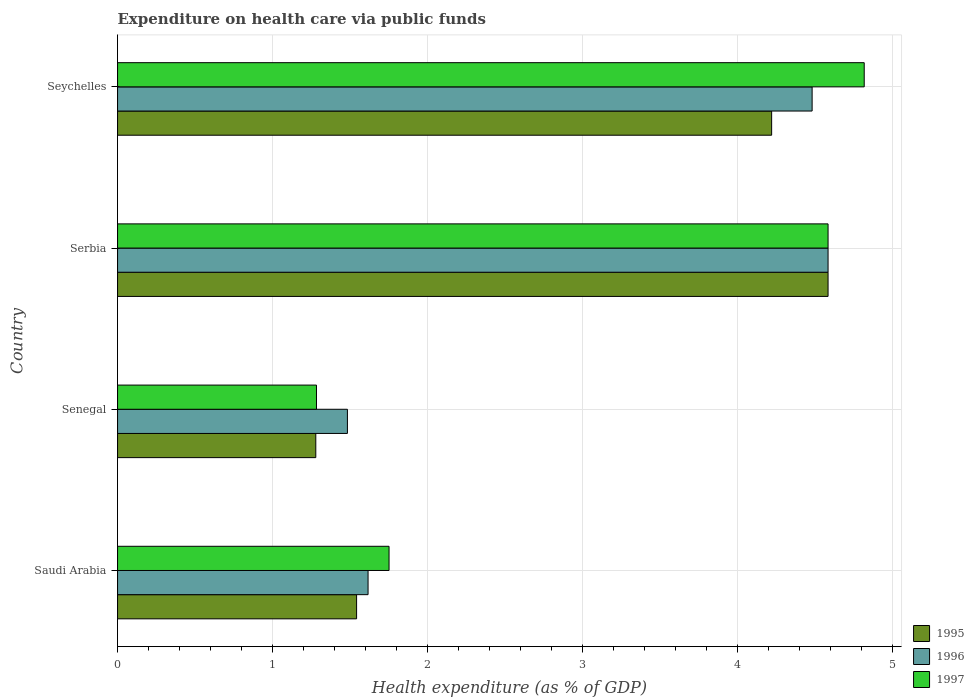How many different coloured bars are there?
Provide a short and direct response. 3. How many bars are there on the 2nd tick from the top?
Provide a short and direct response. 3. What is the label of the 2nd group of bars from the top?
Your answer should be compact. Serbia. In how many cases, is the number of bars for a given country not equal to the number of legend labels?
Provide a succinct answer. 0. What is the expenditure made on health care in 1996 in Saudi Arabia?
Your answer should be very brief. 1.62. Across all countries, what is the maximum expenditure made on health care in 1997?
Your answer should be very brief. 4.82. Across all countries, what is the minimum expenditure made on health care in 1995?
Provide a short and direct response. 1.28. In which country was the expenditure made on health care in 1995 maximum?
Offer a very short reply. Serbia. In which country was the expenditure made on health care in 1997 minimum?
Ensure brevity in your answer.  Senegal. What is the total expenditure made on health care in 1997 in the graph?
Provide a succinct answer. 12.44. What is the difference between the expenditure made on health care in 1996 in Senegal and that in Seychelles?
Provide a short and direct response. -3. What is the difference between the expenditure made on health care in 1995 in Serbia and the expenditure made on health care in 1996 in Seychelles?
Offer a terse response. 0.1. What is the average expenditure made on health care in 1995 per country?
Ensure brevity in your answer.  2.91. What is the difference between the expenditure made on health care in 1997 and expenditure made on health care in 1995 in Senegal?
Ensure brevity in your answer.  0. In how many countries, is the expenditure made on health care in 1997 greater than 4.4 %?
Keep it short and to the point. 2. What is the ratio of the expenditure made on health care in 1997 in Saudi Arabia to that in Serbia?
Provide a succinct answer. 0.38. Is the difference between the expenditure made on health care in 1997 in Senegal and Seychelles greater than the difference between the expenditure made on health care in 1995 in Senegal and Seychelles?
Keep it short and to the point. No. What is the difference between the highest and the second highest expenditure made on health care in 1995?
Provide a succinct answer. 0.36. What is the difference between the highest and the lowest expenditure made on health care in 1997?
Keep it short and to the point. 3.54. What does the 3rd bar from the top in Saudi Arabia represents?
Give a very brief answer. 1995. Is it the case that in every country, the sum of the expenditure made on health care in 1997 and expenditure made on health care in 1996 is greater than the expenditure made on health care in 1995?
Provide a short and direct response. Yes. What is the difference between two consecutive major ticks on the X-axis?
Keep it short and to the point. 1. Does the graph contain any zero values?
Your answer should be compact. No. Does the graph contain grids?
Give a very brief answer. Yes. How many legend labels are there?
Give a very brief answer. 3. What is the title of the graph?
Your answer should be very brief. Expenditure on health care via public funds. What is the label or title of the X-axis?
Provide a short and direct response. Health expenditure (as % of GDP). What is the Health expenditure (as % of GDP) in 1995 in Saudi Arabia?
Your answer should be compact. 1.54. What is the Health expenditure (as % of GDP) in 1996 in Saudi Arabia?
Give a very brief answer. 1.62. What is the Health expenditure (as % of GDP) of 1997 in Saudi Arabia?
Your response must be concise. 1.75. What is the Health expenditure (as % of GDP) of 1995 in Senegal?
Offer a very short reply. 1.28. What is the Health expenditure (as % of GDP) of 1996 in Senegal?
Provide a short and direct response. 1.48. What is the Health expenditure (as % of GDP) of 1997 in Senegal?
Give a very brief answer. 1.28. What is the Health expenditure (as % of GDP) of 1995 in Serbia?
Provide a succinct answer. 4.59. What is the Health expenditure (as % of GDP) in 1996 in Serbia?
Your response must be concise. 4.59. What is the Health expenditure (as % of GDP) in 1997 in Serbia?
Provide a short and direct response. 4.59. What is the Health expenditure (as % of GDP) in 1995 in Seychelles?
Ensure brevity in your answer.  4.22. What is the Health expenditure (as % of GDP) of 1996 in Seychelles?
Ensure brevity in your answer.  4.48. What is the Health expenditure (as % of GDP) of 1997 in Seychelles?
Provide a short and direct response. 4.82. Across all countries, what is the maximum Health expenditure (as % of GDP) in 1995?
Make the answer very short. 4.59. Across all countries, what is the maximum Health expenditure (as % of GDP) of 1996?
Your response must be concise. 4.59. Across all countries, what is the maximum Health expenditure (as % of GDP) of 1997?
Your response must be concise. 4.82. Across all countries, what is the minimum Health expenditure (as % of GDP) of 1995?
Your answer should be very brief. 1.28. Across all countries, what is the minimum Health expenditure (as % of GDP) in 1996?
Your response must be concise. 1.48. Across all countries, what is the minimum Health expenditure (as % of GDP) of 1997?
Your answer should be compact. 1.28. What is the total Health expenditure (as % of GDP) in 1995 in the graph?
Your response must be concise. 11.63. What is the total Health expenditure (as % of GDP) in 1996 in the graph?
Make the answer very short. 12.17. What is the total Health expenditure (as % of GDP) of 1997 in the graph?
Provide a short and direct response. 12.44. What is the difference between the Health expenditure (as % of GDP) of 1995 in Saudi Arabia and that in Senegal?
Make the answer very short. 0.26. What is the difference between the Health expenditure (as % of GDP) of 1996 in Saudi Arabia and that in Senegal?
Offer a terse response. 0.13. What is the difference between the Health expenditure (as % of GDP) in 1997 in Saudi Arabia and that in Senegal?
Your answer should be very brief. 0.47. What is the difference between the Health expenditure (as % of GDP) in 1995 in Saudi Arabia and that in Serbia?
Offer a terse response. -3.04. What is the difference between the Health expenditure (as % of GDP) of 1996 in Saudi Arabia and that in Serbia?
Ensure brevity in your answer.  -2.97. What is the difference between the Health expenditure (as % of GDP) of 1997 in Saudi Arabia and that in Serbia?
Make the answer very short. -2.83. What is the difference between the Health expenditure (as % of GDP) in 1995 in Saudi Arabia and that in Seychelles?
Your response must be concise. -2.68. What is the difference between the Health expenditure (as % of GDP) in 1996 in Saudi Arabia and that in Seychelles?
Your answer should be compact. -2.87. What is the difference between the Health expenditure (as % of GDP) in 1997 in Saudi Arabia and that in Seychelles?
Your answer should be compact. -3.07. What is the difference between the Health expenditure (as % of GDP) of 1995 in Senegal and that in Serbia?
Offer a very short reply. -3.31. What is the difference between the Health expenditure (as % of GDP) in 1996 in Senegal and that in Serbia?
Make the answer very short. -3.1. What is the difference between the Health expenditure (as % of GDP) in 1997 in Senegal and that in Serbia?
Provide a short and direct response. -3.3. What is the difference between the Health expenditure (as % of GDP) of 1995 in Senegal and that in Seychelles?
Offer a terse response. -2.94. What is the difference between the Health expenditure (as % of GDP) of 1996 in Senegal and that in Seychelles?
Offer a terse response. -3. What is the difference between the Health expenditure (as % of GDP) in 1997 in Senegal and that in Seychelles?
Provide a succinct answer. -3.54. What is the difference between the Health expenditure (as % of GDP) in 1995 in Serbia and that in Seychelles?
Your answer should be compact. 0.36. What is the difference between the Health expenditure (as % of GDP) of 1996 in Serbia and that in Seychelles?
Offer a very short reply. 0.1. What is the difference between the Health expenditure (as % of GDP) of 1997 in Serbia and that in Seychelles?
Make the answer very short. -0.23. What is the difference between the Health expenditure (as % of GDP) in 1995 in Saudi Arabia and the Health expenditure (as % of GDP) in 1996 in Senegal?
Your answer should be compact. 0.06. What is the difference between the Health expenditure (as % of GDP) of 1995 in Saudi Arabia and the Health expenditure (as % of GDP) of 1997 in Senegal?
Offer a terse response. 0.26. What is the difference between the Health expenditure (as % of GDP) in 1996 in Saudi Arabia and the Health expenditure (as % of GDP) in 1997 in Senegal?
Provide a succinct answer. 0.33. What is the difference between the Health expenditure (as % of GDP) in 1995 in Saudi Arabia and the Health expenditure (as % of GDP) in 1996 in Serbia?
Offer a terse response. -3.04. What is the difference between the Health expenditure (as % of GDP) of 1995 in Saudi Arabia and the Health expenditure (as % of GDP) of 1997 in Serbia?
Your response must be concise. -3.04. What is the difference between the Health expenditure (as % of GDP) in 1996 in Saudi Arabia and the Health expenditure (as % of GDP) in 1997 in Serbia?
Offer a terse response. -2.97. What is the difference between the Health expenditure (as % of GDP) of 1995 in Saudi Arabia and the Health expenditure (as % of GDP) of 1996 in Seychelles?
Your answer should be very brief. -2.94. What is the difference between the Health expenditure (as % of GDP) in 1995 in Saudi Arabia and the Health expenditure (as % of GDP) in 1997 in Seychelles?
Provide a succinct answer. -3.28. What is the difference between the Health expenditure (as % of GDP) of 1996 in Saudi Arabia and the Health expenditure (as % of GDP) of 1997 in Seychelles?
Keep it short and to the point. -3.2. What is the difference between the Health expenditure (as % of GDP) of 1995 in Senegal and the Health expenditure (as % of GDP) of 1996 in Serbia?
Your answer should be very brief. -3.31. What is the difference between the Health expenditure (as % of GDP) of 1995 in Senegal and the Health expenditure (as % of GDP) of 1997 in Serbia?
Ensure brevity in your answer.  -3.31. What is the difference between the Health expenditure (as % of GDP) in 1996 in Senegal and the Health expenditure (as % of GDP) in 1997 in Serbia?
Your answer should be very brief. -3.1. What is the difference between the Health expenditure (as % of GDP) in 1995 in Senegal and the Health expenditure (as % of GDP) in 1996 in Seychelles?
Your answer should be compact. -3.2. What is the difference between the Health expenditure (as % of GDP) of 1995 in Senegal and the Health expenditure (as % of GDP) of 1997 in Seychelles?
Your response must be concise. -3.54. What is the difference between the Health expenditure (as % of GDP) of 1996 in Senegal and the Health expenditure (as % of GDP) of 1997 in Seychelles?
Your answer should be compact. -3.34. What is the difference between the Health expenditure (as % of GDP) in 1995 in Serbia and the Health expenditure (as % of GDP) in 1996 in Seychelles?
Keep it short and to the point. 0.1. What is the difference between the Health expenditure (as % of GDP) of 1995 in Serbia and the Health expenditure (as % of GDP) of 1997 in Seychelles?
Keep it short and to the point. -0.23. What is the difference between the Health expenditure (as % of GDP) in 1996 in Serbia and the Health expenditure (as % of GDP) in 1997 in Seychelles?
Your answer should be very brief. -0.23. What is the average Health expenditure (as % of GDP) in 1995 per country?
Offer a very short reply. 2.91. What is the average Health expenditure (as % of GDP) in 1996 per country?
Your response must be concise. 3.04. What is the average Health expenditure (as % of GDP) in 1997 per country?
Give a very brief answer. 3.11. What is the difference between the Health expenditure (as % of GDP) in 1995 and Health expenditure (as % of GDP) in 1996 in Saudi Arabia?
Give a very brief answer. -0.07. What is the difference between the Health expenditure (as % of GDP) in 1995 and Health expenditure (as % of GDP) in 1997 in Saudi Arabia?
Your answer should be very brief. -0.21. What is the difference between the Health expenditure (as % of GDP) in 1996 and Health expenditure (as % of GDP) in 1997 in Saudi Arabia?
Ensure brevity in your answer.  -0.14. What is the difference between the Health expenditure (as % of GDP) of 1995 and Health expenditure (as % of GDP) of 1996 in Senegal?
Your answer should be very brief. -0.2. What is the difference between the Health expenditure (as % of GDP) of 1995 and Health expenditure (as % of GDP) of 1997 in Senegal?
Your response must be concise. -0. What is the difference between the Health expenditure (as % of GDP) in 1996 and Health expenditure (as % of GDP) in 1997 in Senegal?
Provide a succinct answer. 0.2. What is the difference between the Health expenditure (as % of GDP) in 1995 and Health expenditure (as % of GDP) in 1997 in Serbia?
Offer a terse response. 0. What is the difference between the Health expenditure (as % of GDP) of 1995 and Health expenditure (as % of GDP) of 1996 in Seychelles?
Provide a succinct answer. -0.26. What is the difference between the Health expenditure (as % of GDP) of 1995 and Health expenditure (as % of GDP) of 1997 in Seychelles?
Offer a very short reply. -0.6. What is the difference between the Health expenditure (as % of GDP) of 1996 and Health expenditure (as % of GDP) of 1997 in Seychelles?
Offer a terse response. -0.34. What is the ratio of the Health expenditure (as % of GDP) in 1995 in Saudi Arabia to that in Senegal?
Provide a short and direct response. 1.21. What is the ratio of the Health expenditure (as % of GDP) of 1996 in Saudi Arabia to that in Senegal?
Keep it short and to the point. 1.09. What is the ratio of the Health expenditure (as % of GDP) in 1997 in Saudi Arabia to that in Senegal?
Provide a short and direct response. 1.36. What is the ratio of the Health expenditure (as % of GDP) in 1995 in Saudi Arabia to that in Serbia?
Keep it short and to the point. 0.34. What is the ratio of the Health expenditure (as % of GDP) in 1996 in Saudi Arabia to that in Serbia?
Make the answer very short. 0.35. What is the ratio of the Health expenditure (as % of GDP) of 1997 in Saudi Arabia to that in Serbia?
Provide a succinct answer. 0.38. What is the ratio of the Health expenditure (as % of GDP) of 1995 in Saudi Arabia to that in Seychelles?
Ensure brevity in your answer.  0.37. What is the ratio of the Health expenditure (as % of GDP) in 1996 in Saudi Arabia to that in Seychelles?
Offer a terse response. 0.36. What is the ratio of the Health expenditure (as % of GDP) in 1997 in Saudi Arabia to that in Seychelles?
Offer a terse response. 0.36. What is the ratio of the Health expenditure (as % of GDP) of 1995 in Senegal to that in Serbia?
Your response must be concise. 0.28. What is the ratio of the Health expenditure (as % of GDP) in 1996 in Senegal to that in Serbia?
Your answer should be compact. 0.32. What is the ratio of the Health expenditure (as % of GDP) of 1997 in Senegal to that in Serbia?
Offer a very short reply. 0.28. What is the ratio of the Health expenditure (as % of GDP) in 1995 in Senegal to that in Seychelles?
Your answer should be very brief. 0.3. What is the ratio of the Health expenditure (as % of GDP) of 1996 in Senegal to that in Seychelles?
Provide a short and direct response. 0.33. What is the ratio of the Health expenditure (as % of GDP) of 1997 in Senegal to that in Seychelles?
Your response must be concise. 0.27. What is the ratio of the Health expenditure (as % of GDP) in 1995 in Serbia to that in Seychelles?
Provide a short and direct response. 1.09. What is the ratio of the Health expenditure (as % of GDP) in 1997 in Serbia to that in Seychelles?
Your answer should be compact. 0.95. What is the difference between the highest and the second highest Health expenditure (as % of GDP) in 1995?
Offer a very short reply. 0.36. What is the difference between the highest and the second highest Health expenditure (as % of GDP) in 1996?
Give a very brief answer. 0.1. What is the difference between the highest and the second highest Health expenditure (as % of GDP) in 1997?
Provide a succinct answer. 0.23. What is the difference between the highest and the lowest Health expenditure (as % of GDP) in 1995?
Your answer should be very brief. 3.31. What is the difference between the highest and the lowest Health expenditure (as % of GDP) of 1996?
Your response must be concise. 3.1. What is the difference between the highest and the lowest Health expenditure (as % of GDP) in 1997?
Provide a short and direct response. 3.54. 